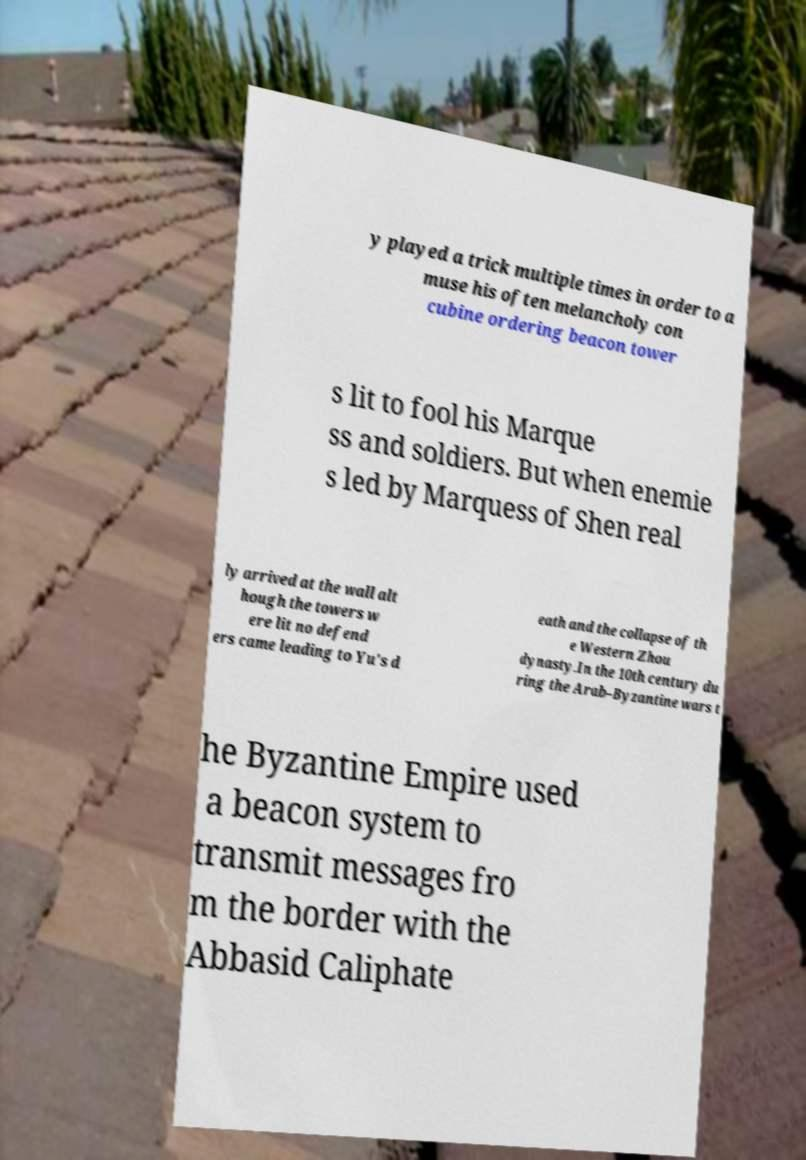Could you extract and type out the text from this image? y played a trick multiple times in order to a muse his often melancholy con cubine ordering beacon tower s lit to fool his Marque ss and soldiers. But when enemie s led by Marquess of Shen real ly arrived at the wall alt hough the towers w ere lit no defend ers came leading to Yu's d eath and the collapse of th e Western Zhou dynasty.In the 10th century du ring the Arab–Byzantine wars t he Byzantine Empire used a beacon system to transmit messages fro m the border with the Abbasid Caliphate 